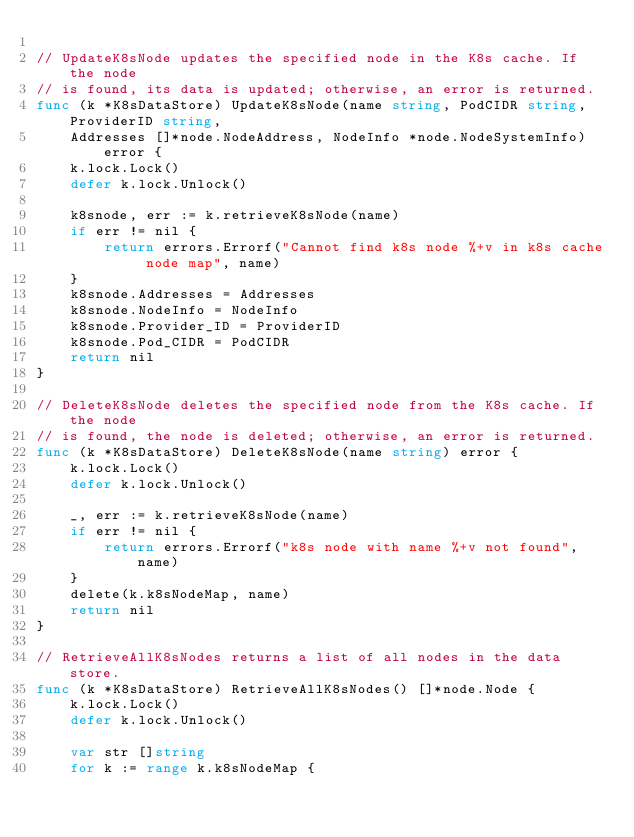Convert code to text. <code><loc_0><loc_0><loc_500><loc_500><_Go_>
// UpdateK8sNode updates the specified node in the K8s cache. If the node
// is found, its data is updated; otherwise, an error is returned.
func (k *K8sDataStore) UpdateK8sNode(name string, PodCIDR string, ProviderID string,
	Addresses []*node.NodeAddress, NodeInfo *node.NodeSystemInfo) error {
	k.lock.Lock()
	defer k.lock.Unlock()

	k8snode, err := k.retrieveK8sNode(name)
	if err != nil {
		return errors.Errorf("Cannot find k8s node %+v in k8s cache node map", name)
	}
	k8snode.Addresses = Addresses
	k8snode.NodeInfo = NodeInfo
	k8snode.Provider_ID = ProviderID
	k8snode.Pod_CIDR = PodCIDR
	return nil
}

// DeleteK8sNode deletes the specified node from the K8s cache. If the node
// is found, the node is deleted; otherwise, an error is returned.
func (k *K8sDataStore) DeleteK8sNode(name string) error {
	k.lock.Lock()
	defer k.lock.Unlock()

	_, err := k.retrieveK8sNode(name)
	if err != nil {
		return errors.Errorf("k8s node with name %+v not found", name)
	}
	delete(k.k8sNodeMap, name)
	return nil
}

// RetrieveAllK8sNodes returns a list of all nodes in the data store.
func (k *K8sDataStore) RetrieveAllK8sNodes() []*node.Node {
	k.lock.Lock()
	defer k.lock.Unlock()

	var str []string
	for k := range k.k8sNodeMap {</code> 